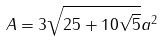<formula> <loc_0><loc_0><loc_500><loc_500>A = 3 \sqrt { 2 5 + 1 0 \sqrt { 5 } } a ^ { 2 }</formula> 